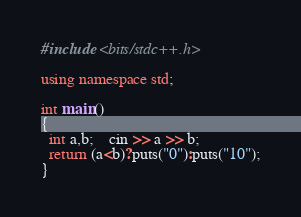Convert code to text. <code><loc_0><loc_0><loc_500><loc_500><_C++_>#include <bits/stdc++.h>

using namespace std;

int main()
{
  int a,b;	cin >> a >> b;
  return (a<b)?puts("0"):puts("10");
}
</code> 